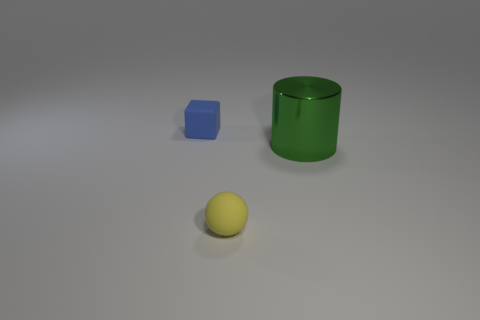Add 3 yellow balls. How many objects exist? 6 Subtract all blocks. How many objects are left? 2 Add 2 small things. How many small things exist? 4 Subtract 1 blue blocks. How many objects are left? 2 Subtract all brown cubes. Subtract all yellow spheres. How many cubes are left? 1 Subtract all red spheres. How many gray cubes are left? 0 Subtract all red metallic cubes. Subtract all green cylinders. How many objects are left? 2 Add 3 matte cubes. How many matte cubes are left? 4 